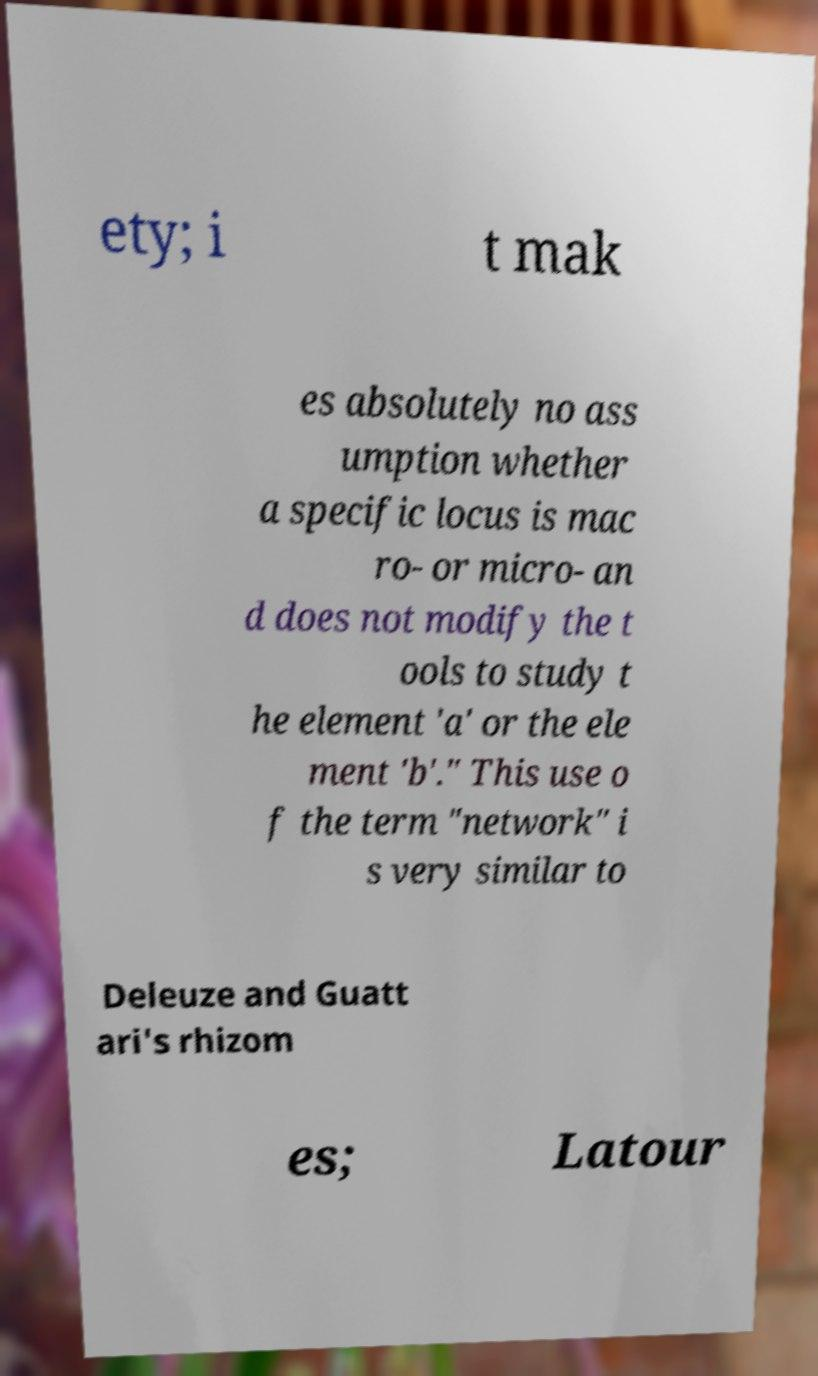There's text embedded in this image that I need extracted. Can you transcribe it verbatim? ety; i t mak es absolutely no ass umption whether a specific locus is mac ro- or micro- an d does not modify the t ools to study t he element 'a' or the ele ment 'b'." This use o f the term "network" i s very similar to Deleuze and Guatt ari's rhizom es; Latour 